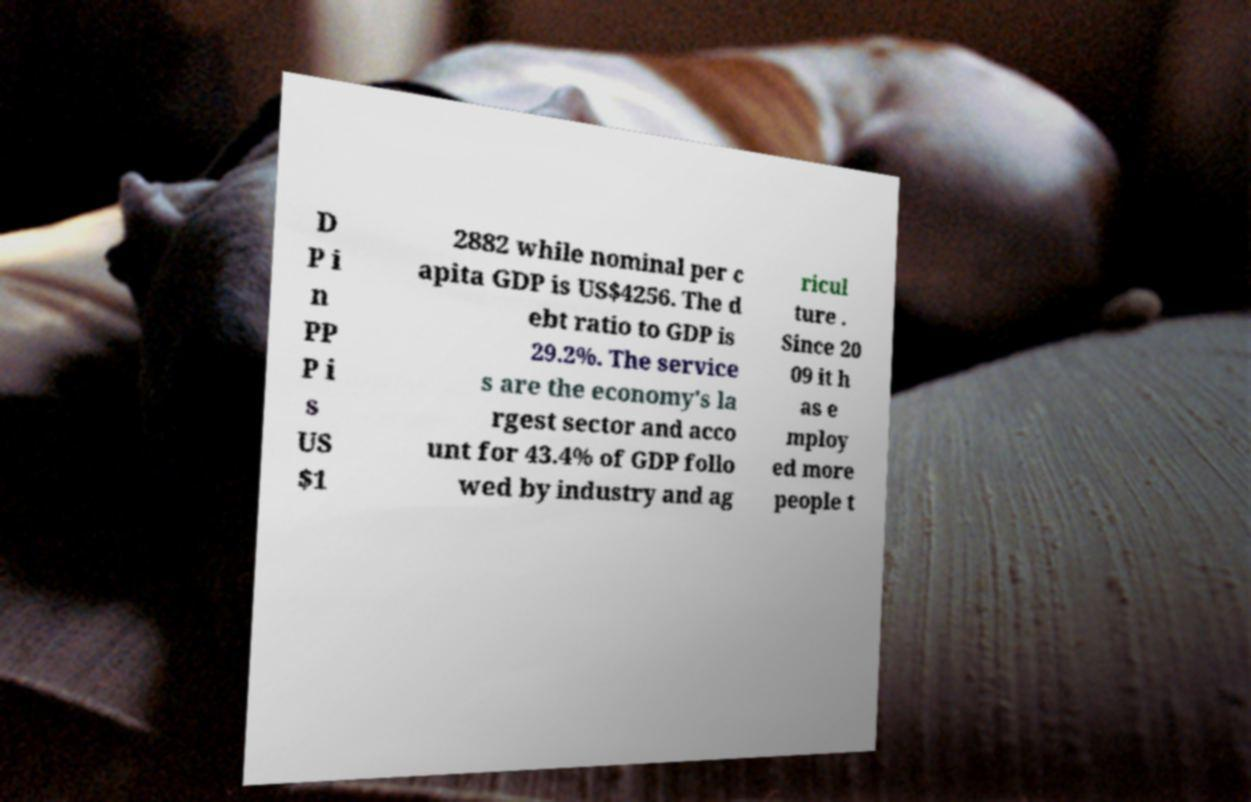Please identify and transcribe the text found in this image. D P i n PP P i s US $1 2882 while nominal per c apita GDP is US$4256. The d ebt ratio to GDP is 29.2%. The service s are the economy's la rgest sector and acco unt for 43.4% of GDP follo wed by industry and ag ricul ture . Since 20 09 it h as e mploy ed more people t 